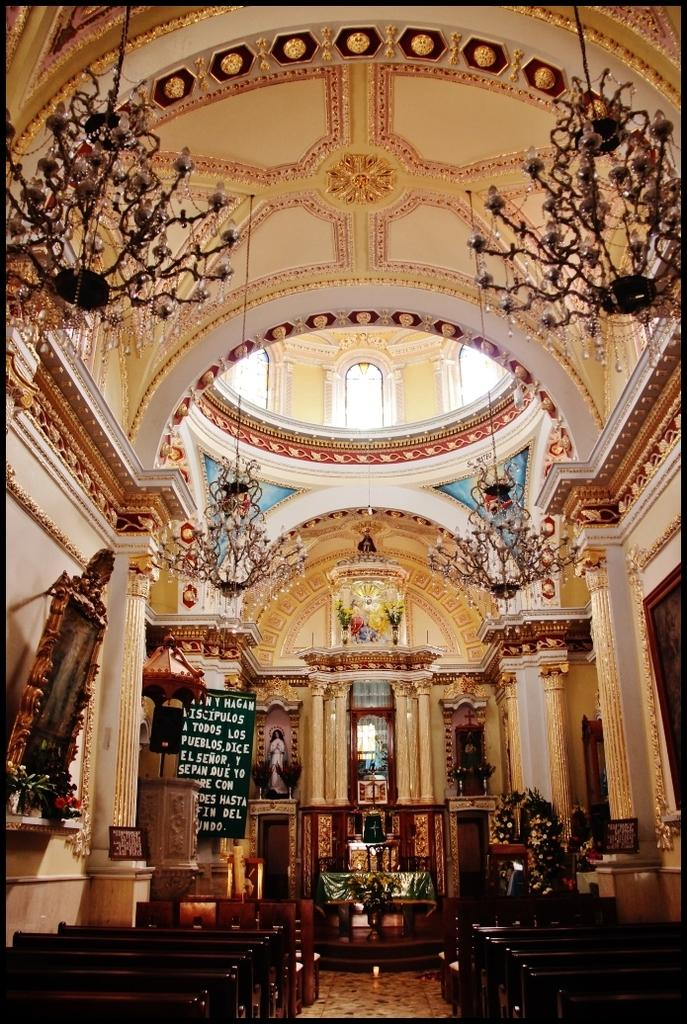What type of building is shown in the image? The image shows the inner view of a church. What architectural features can be seen in the church? There are pillars in the church. What type of seating is available in the church? There are benches in the church. What type of decorations are present in the church? There are photo frames and boards in the church. What type of lighting is present in the church? There are chandeliers in the church. What type of fang can be seen hanging from the chandeliers in the image? There are no fangs present in the image, and the chandeliers do not have any fangs hanging from them. 